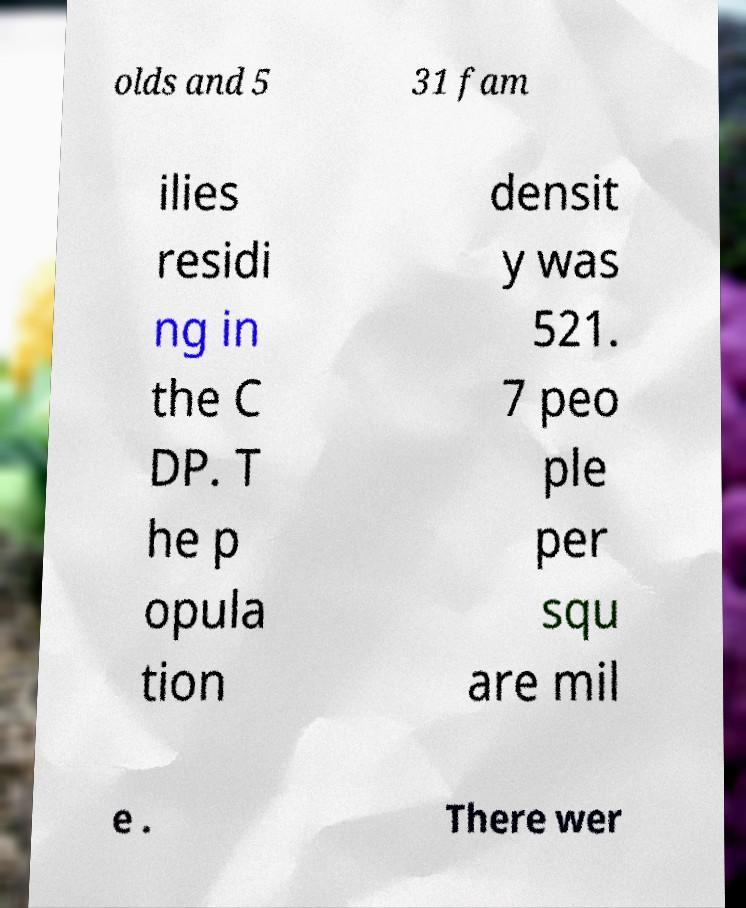There's text embedded in this image that I need extracted. Can you transcribe it verbatim? olds and 5 31 fam ilies residi ng in the C DP. T he p opula tion densit y was 521. 7 peo ple per squ are mil e . There wer 